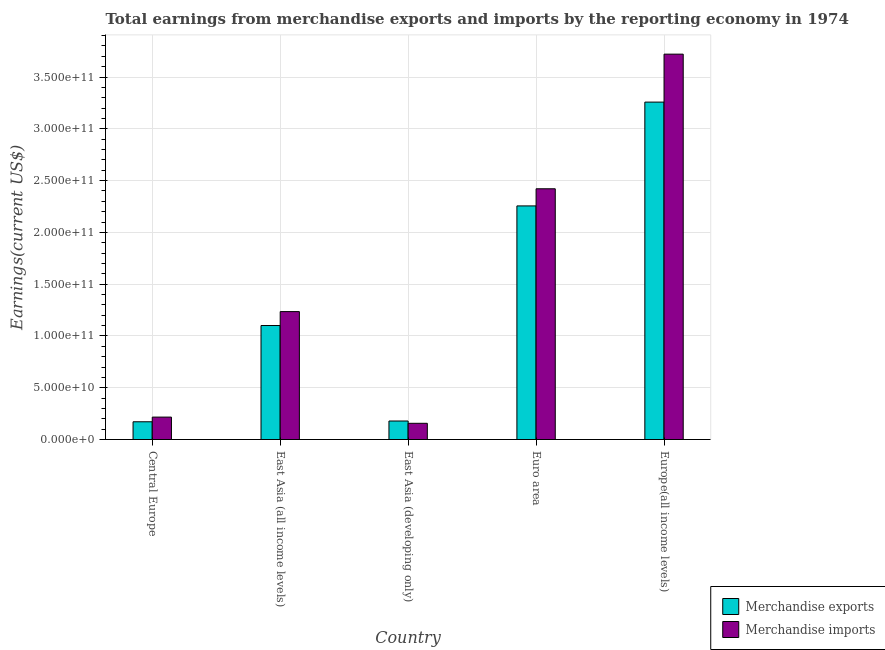How many groups of bars are there?
Keep it short and to the point. 5. Are the number of bars on each tick of the X-axis equal?
Your answer should be very brief. Yes. What is the label of the 2nd group of bars from the left?
Your answer should be compact. East Asia (all income levels). In how many cases, is the number of bars for a given country not equal to the number of legend labels?
Your answer should be compact. 0. What is the earnings from merchandise imports in East Asia (developing only)?
Provide a succinct answer. 1.57e+1. Across all countries, what is the maximum earnings from merchandise exports?
Offer a terse response. 3.26e+11. Across all countries, what is the minimum earnings from merchandise exports?
Your answer should be very brief. 1.71e+1. In which country was the earnings from merchandise exports maximum?
Your answer should be compact. Europe(all income levels). In which country was the earnings from merchandise imports minimum?
Provide a short and direct response. East Asia (developing only). What is the total earnings from merchandise exports in the graph?
Your answer should be very brief. 6.96e+11. What is the difference between the earnings from merchandise imports in Central Europe and that in East Asia (all income levels)?
Ensure brevity in your answer.  -1.02e+11. What is the difference between the earnings from merchandise exports in East Asia (developing only) and the earnings from merchandise imports in Europe(all income levels)?
Your response must be concise. -3.54e+11. What is the average earnings from merchandise exports per country?
Offer a very short reply. 1.39e+11. What is the difference between the earnings from merchandise imports and earnings from merchandise exports in East Asia (developing only)?
Give a very brief answer. -2.22e+09. In how many countries, is the earnings from merchandise exports greater than 290000000000 US$?
Your response must be concise. 1. What is the ratio of the earnings from merchandise imports in East Asia (developing only) to that in Euro area?
Provide a succinct answer. 0.06. Is the difference between the earnings from merchandise exports in Euro area and Europe(all income levels) greater than the difference between the earnings from merchandise imports in Euro area and Europe(all income levels)?
Make the answer very short. Yes. What is the difference between the highest and the second highest earnings from merchandise exports?
Keep it short and to the point. 1.00e+11. What is the difference between the highest and the lowest earnings from merchandise imports?
Your response must be concise. 3.56e+11. In how many countries, is the earnings from merchandise imports greater than the average earnings from merchandise imports taken over all countries?
Give a very brief answer. 2. Is the sum of the earnings from merchandise imports in Euro area and Europe(all income levels) greater than the maximum earnings from merchandise exports across all countries?
Provide a succinct answer. Yes. What does the 1st bar from the left in East Asia (all income levels) represents?
Your answer should be very brief. Merchandise exports. Are all the bars in the graph horizontal?
Keep it short and to the point. No. How many countries are there in the graph?
Offer a terse response. 5. What is the difference between two consecutive major ticks on the Y-axis?
Provide a succinct answer. 5.00e+1. Are the values on the major ticks of Y-axis written in scientific E-notation?
Offer a very short reply. Yes. Does the graph contain any zero values?
Provide a short and direct response. No. Does the graph contain grids?
Provide a succinct answer. Yes. How many legend labels are there?
Make the answer very short. 2. How are the legend labels stacked?
Provide a short and direct response. Vertical. What is the title of the graph?
Offer a very short reply. Total earnings from merchandise exports and imports by the reporting economy in 1974. What is the label or title of the Y-axis?
Make the answer very short. Earnings(current US$). What is the Earnings(current US$) of Merchandise exports in Central Europe?
Your answer should be compact. 1.71e+1. What is the Earnings(current US$) of Merchandise imports in Central Europe?
Offer a very short reply. 2.16e+1. What is the Earnings(current US$) in Merchandise exports in East Asia (all income levels)?
Provide a short and direct response. 1.10e+11. What is the Earnings(current US$) of Merchandise imports in East Asia (all income levels)?
Offer a terse response. 1.24e+11. What is the Earnings(current US$) of Merchandise exports in East Asia (developing only)?
Give a very brief answer. 1.79e+1. What is the Earnings(current US$) in Merchandise imports in East Asia (developing only)?
Provide a succinct answer. 1.57e+1. What is the Earnings(current US$) of Merchandise exports in Euro area?
Your response must be concise. 2.26e+11. What is the Earnings(current US$) in Merchandise imports in Euro area?
Ensure brevity in your answer.  2.42e+11. What is the Earnings(current US$) of Merchandise exports in Europe(all income levels)?
Offer a terse response. 3.26e+11. What is the Earnings(current US$) of Merchandise imports in Europe(all income levels)?
Keep it short and to the point. 3.72e+11. Across all countries, what is the maximum Earnings(current US$) of Merchandise exports?
Keep it short and to the point. 3.26e+11. Across all countries, what is the maximum Earnings(current US$) in Merchandise imports?
Ensure brevity in your answer.  3.72e+11. Across all countries, what is the minimum Earnings(current US$) in Merchandise exports?
Offer a terse response. 1.71e+1. Across all countries, what is the minimum Earnings(current US$) of Merchandise imports?
Your response must be concise. 1.57e+1. What is the total Earnings(current US$) in Merchandise exports in the graph?
Ensure brevity in your answer.  6.96e+11. What is the total Earnings(current US$) of Merchandise imports in the graph?
Ensure brevity in your answer.  7.75e+11. What is the difference between the Earnings(current US$) of Merchandise exports in Central Europe and that in East Asia (all income levels)?
Offer a terse response. -9.30e+1. What is the difference between the Earnings(current US$) of Merchandise imports in Central Europe and that in East Asia (all income levels)?
Provide a short and direct response. -1.02e+11. What is the difference between the Earnings(current US$) in Merchandise exports in Central Europe and that in East Asia (developing only)?
Give a very brief answer. -7.42e+08. What is the difference between the Earnings(current US$) of Merchandise imports in Central Europe and that in East Asia (developing only)?
Your answer should be compact. 5.99e+09. What is the difference between the Earnings(current US$) in Merchandise exports in Central Europe and that in Euro area?
Offer a very short reply. -2.08e+11. What is the difference between the Earnings(current US$) in Merchandise imports in Central Europe and that in Euro area?
Offer a very short reply. -2.20e+11. What is the difference between the Earnings(current US$) in Merchandise exports in Central Europe and that in Europe(all income levels)?
Provide a short and direct response. -3.09e+11. What is the difference between the Earnings(current US$) in Merchandise imports in Central Europe and that in Europe(all income levels)?
Provide a short and direct response. -3.50e+11. What is the difference between the Earnings(current US$) in Merchandise exports in East Asia (all income levels) and that in East Asia (developing only)?
Your response must be concise. 9.22e+1. What is the difference between the Earnings(current US$) in Merchandise imports in East Asia (all income levels) and that in East Asia (developing only)?
Your answer should be very brief. 1.08e+11. What is the difference between the Earnings(current US$) in Merchandise exports in East Asia (all income levels) and that in Euro area?
Your response must be concise. -1.15e+11. What is the difference between the Earnings(current US$) of Merchandise imports in East Asia (all income levels) and that in Euro area?
Provide a short and direct response. -1.19e+11. What is the difference between the Earnings(current US$) in Merchandise exports in East Asia (all income levels) and that in Europe(all income levels)?
Your answer should be compact. -2.16e+11. What is the difference between the Earnings(current US$) in Merchandise imports in East Asia (all income levels) and that in Europe(all income levels)?
Make the answer very short. -2.49e+11. What is the difference between the Earnings(current US$) in Merchandise exports in East Asia (developing only) and that in Euro area?
Make the answer very short. -2.08e+11. What is the difference between the Earnings(current US$) of Merchandise imports in East Asia (developing only) and that in Euro area?
Your answer should be compact. -2.26e+11. What is the difference between the Earnings(current US$) in Merchandise exports in East Asia (developing only) and that in Europe(all income levels)?
Provide a short and direct response. -3.08e+11. What is the difference between the Earnings(current US$) of Merchandise imports in East Asia (developing only) and that in Europe(all income levels)?
Provide a short and direct response. -3.56e+11. What is the difference between the Earnings(current US$) of Merchandise exports in Euro area and that in Europe(all income levels)?
Offer a very short reply. -1.00e+11. What is the difference between the Earnings(current US$) of Merchandise imports in Euro area and that in Europe(all income levels)?
Offer a very short reply. -1.30e+11. What is the difference between the Earnings(current US$) in Merchandise exports in Central Europe and the Earnings(current US$) in Merchandise imports in East Asia (all income levels)?
Provide a short and direct response. -1.06e+11. What is the difference between the Earnings(current US$) in Merchandise exports in Central Europe and the Earnings(current US$) in Merchandise imports in East Asia (developing only)?
Offer a terse response. 1.48e+09. What is the difference between the Earnings(current US$) of Merchandise exports in Central Europe and the Earnings(current US$) of Merchandise imports in Euro area?
Your response must be concise. -2.25e+11. What is the difference between the Earnings(current US$) of Merchandise exports in Central Europe and the Earnings(current US$) of Merchandise imports in Europe(all income levels)?
Ensure brevity in your answer.  -3.55e+11. What is the difference between the Earnings(current US$) in Merchandise exports in East Asia (all income levels) and the Earnings(current US$) in Merchandise imports in East Asia (developing only)?
Keep it short and to the point. 9.44e+1. What is the difference between the Earnings(current US$) in Merchandise exports in East Asia (all income levels) and the Earnings(current US$) in Merchandise imports in Euro area?
Provide a succinct answer. -1.32e+11. What is the difference between the Earnings(current US$) in Merchandise exports in East Asia (all income levels) and the Earnings(current US$) in Merchandise imports in Europe(all income levels)?
Provide a short and direct response. -2.62e+11. What is the difference between the Earnings(current US$) in Merchandise exports in East Asia (developing only) and the Earnings(current US$) in Merchandise imports in Euro area?
Provide a succinct answer. -2.24e+11. What is the difference between the Earnings(current US$) of Merchandise exports in East Asia (developing only) and the Earnings(current US$) of Merchandise imports in Europe(all income levels)?
Your answer should be very brief. -3.54e+11. What is the difference between the Earnings(current US$) of Merchandise exports in Euro area and the Earnings(current US$) of Merchandise imports in Europe(all income levels)?
Offer a terse response. -1.47e+11. What is the average Earnings(current US$) of Merchandise exports per country?
Offer a terse response. 1.39e+11. What is the average Earnings(current US$) of Merchandise imports per country?
Offer a very short reply. 1.55e+11. What is the difference between the Earnings(current US$) of Merchandise exports and Earnings(current US$) of Merchandise imports in Central Europe?
Make the answer very short. -4.52e+09. What is the difference between the Earnings(current US$) in Merchandise exports and Earnings(current US$) in Merchandise imports in East Asia (all income levels)?
Provide a succinct answer. -1.34e+1. What is the difference between the Earnings(current US$) of Merchandise exports and Earnings(current US$) of Merchandise imports in East Asia (developing only)?
Make the answer very short. 2.22e+09. What is the difference between the Earnings(current US$) of Merchandise exports and Earnings(current US$) of Merchandise imports in Euro area?
Provide a succinct answer. -1.66e+1. What is the difference between the Earnings(current US$) of Merchandise exports and Earnings(current US$) of Merchandise imports in Europe(all income levels)?
Give a very brief answer. -4.63e+1. What is the ratio of the Earnings(current US$) in Merchandise exports in Central Europe to that in East Asia (all income levels)?
Your answer should be very brief. 0.16. What is the ratio of the Earnings(current US$) in Merchandise imports in Central Europe to that in East Asia (all income levels)?
Make the answer very short. 0.18. What is the ratio of the Earnings(current US$) in Merchandise exports in Central Europe to that in East Asia (developing only)?
Your response must be concise. 0.96. What is the ratio of the Earnings(current US$) of Merchandise imports in Central Europe to that in East Asia (developing only)?
Offer a terse response. 1.38. What is the ratio of the Earnings(current US$) in Merchandise exports in Central Europe to that in Euro area?
Offer a very short reply. 0.08. What is the ratio of the Earnings(current US$) of Merchandise imports in Central Europe to that in Euro area?
Your answer should be very brief. 0.09. What is the ratio of the Earnings(current US$) of Merchandise exports in Central Europe to that in Europe(all income levels)?
Your answer should be very brief. 0.05. What is the ratio of the Earnings(current US$) of Merchandise imports in Central Europe to that in Europe(all income levels)?
Provide a short and direct response. 0.06. What is the ratio of the Earnings(current US$) in Merchandise exports in East Asia (all income levels) to that in East Asia (developing only)?
Your answer should be very brief. 6.16. What is the ratio of the Earnings(current US$) in Merchandise imports in East Asia (all income levels) to that in East Asia (developing only)?
Your answer should be very brief. 7.89. What is the ratio of the Earnings(current US$) in Merchandise exports in East Asia (all income levels) to that in Euro area?
Give a very brief answer. 0.49. What is the ratio of the Earnings(current US$) of Merchandise imports in East Asia (all income levels) to that in Euro area?
Give a very brief answer. 0.51. What is the ratio of the Earnings(current US$) of Merchandise exports in East Asia (all income levels) to that in Europe(all income levels)?
Offer a very short reply. 0.34. What is the ratio of the Earnings(current US$) of Merchandise imports in East Asia (all income levels) to that in Europe(all income levels)?
Keep it short and to the point. 0.33. What is the ratio of the Earnings(current US$) in Merchandise exports in East Asia (developing only) to that in Euro area?
Provide a short and direct response. 0.08. What is the ratio of the Earnings(current US$) of Merchandise imports in East Asia (developing only) to that in Euro area?
Your answer should be compact. 0.06. What is the ratio of the Earnings(current US$) in Merchandise exports in East Asia (developing only) to that in Europe(all income levels)?
Your answer should be very brief. 0.05. What is the ratio of the Earnings(current US$) in Merchandise imports in East Asia (developing only) to that in Europe(all income levels)?
Provide a succinct answer. 0.04. What is the ratio of the Earnings(current US$) of Merchandise exports in Euro area to that in Europe(all income levels)?
Provide a succinct answer. 0.69. What is the ratio of the Earnings(current US$) in Merchandise imports in Euro area to that in Europe(all income levels)?
Keep it short and to the point. 0.65. What is the difference between the highest and the second highest Earnings(current US$) in Merchandise exports?
Your answer should be very brief. 1.00e+11. What is the difference between the highest and the second highest Earnings(current US$) of Merchandise imports?
Provide a short and direct response. 1.30e+11. What is the difference between the highest and the lowest Earnings(current US$) of Merchandise exports?
Your answer should be compact. 3.09e+11. What is the difference between the highest and the lowest Earnings(current US$) of Merchandise imports?
Your response must be concise. 3.56e+11. 